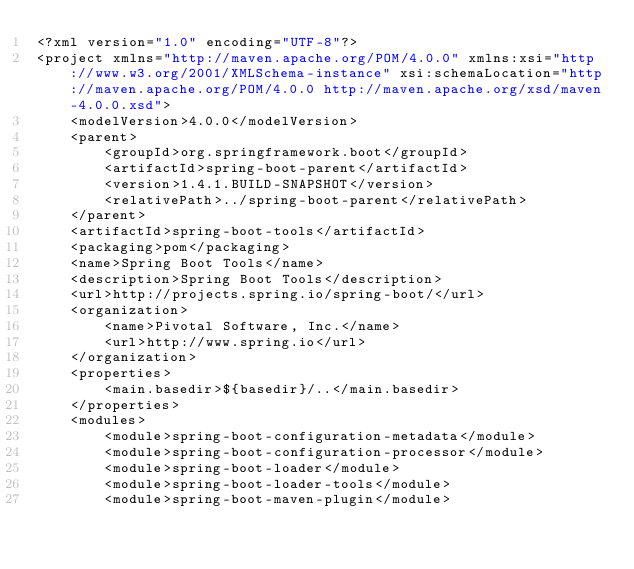<code> <loc_0><loc_0><loc_500><loc_500><_XML_><?xml version="1.0" encoding="UTF-8"?>
<project xmlns="http://maven.apache.org/POM/4.0.0" xmlns:xsi="http://www.w3.org/2001/XMLSchema-instance" xsi:schemaLocation="http://maven.apache.org/POM/4.0.0 http://maven.apache.org/xsd/maven-4.0.0.xsd">
	<modelVersion>4.0.0</modelVersion>
	<parent>
		<groupId>org.springframework.boot</groupId>
		<artifactId>spring-boot-parent</artifactId>
		<version>1.4.1.BUILD-SNAPSHOT</version>
		<relativePath>../spring-boot-parent</relativePath>
	</parent>
	<artifactId>spring-boot-tools</artifactId>
	<packaging>pom</packaging>
	<name>Spring Boot Tools</name>
	<description>Spring Boot Tools</description>
	<url>http://projects.spring.io/spring-boot/</url>
	<organization>
		<name>Pivotal Software, Inc.</name>
		<url>http://www.spring.io</url>
	</organization>
	<properties>
		<main.basedir>${basedir}/..</main.basedir>
	</properties>
	<modules>
		<module>spring-boot-configuration-metadata</module>
		<module>spring-boot-configuration-processor</module>
		<module>spring-boot-loader</module>
		<module>spring-boot-loader-tools</module>
		<module>spring-boot-maven-plugin</module></code> 